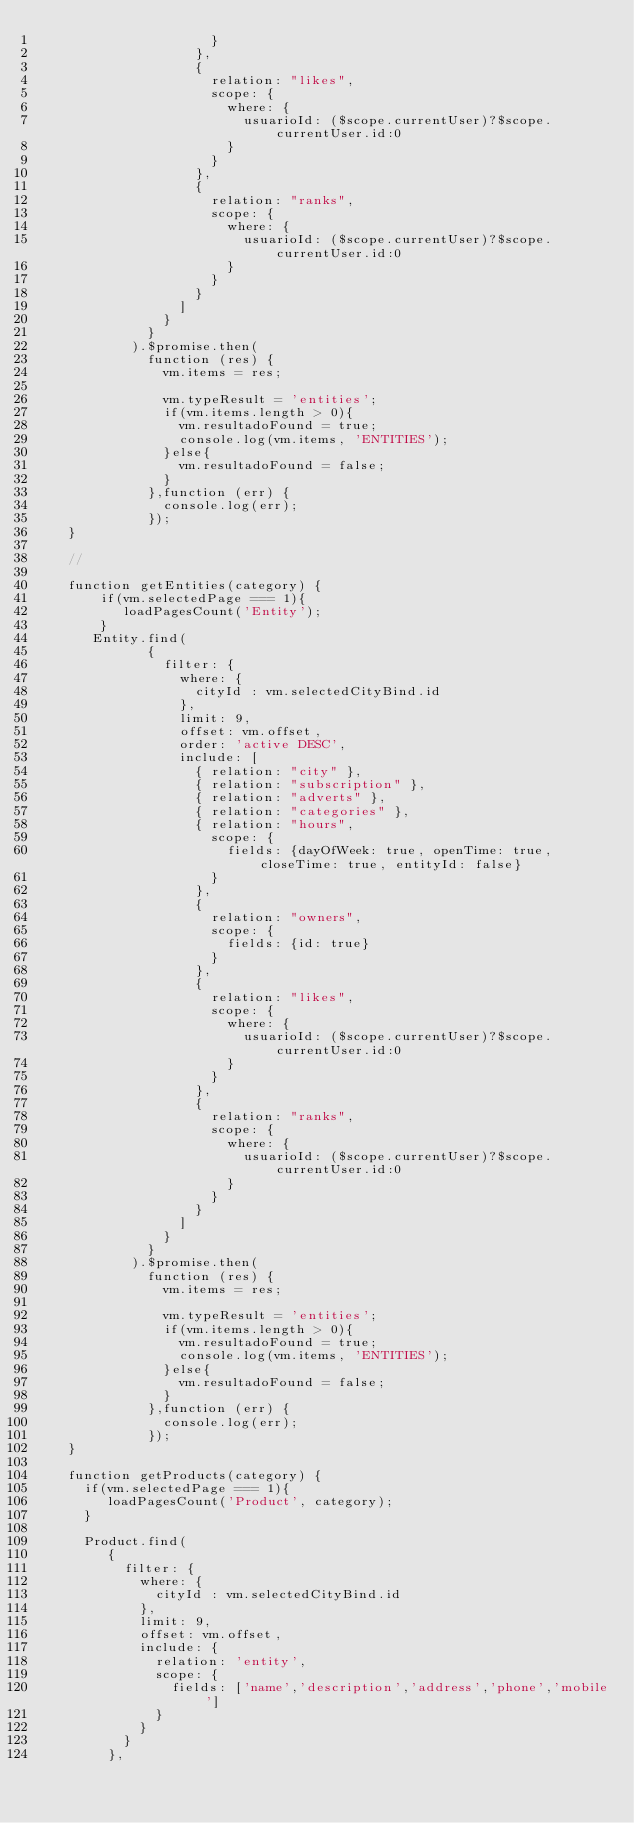Convert code to text. <code><loc_0><loc_0><loc_500><loc_500><_JavaScript_>                      }
                    },
                    {
                      relation: "likes",
                      scope: {
                        where: {
                          usuarioId: ($scope.currentUser)?$scope.currentUser.id:0
                        }
                      }
                    },
                    {
                      relation: "ranks",
                      scope: {
                        where: {
                          usuarioId: ($scope.currentUser)?$scope.currentUser.id:0
                        }
                      }
                    }
                  ]
                }
              }
            ).$promise.then(
              function (res) {
                vm.items = res;
                
                vm.typeResult = 'entities';
                if(vm.items.length > 0){
                  vm.resultadoFound = true;
                  console.log(vm.items, 'ENTITIES');
                }else{
                  vm.resultadoFound = false;
                }
              },function (err) {
                console.log(err);
              });
    }

    //

    function getEntities(category) {
        if(vm.selectedPage === 1){
           loadPagesCount('Entity');
        }
       Entity.find(
              {
                filter: {
                  where: {
                    cityId : vm.selectedCityBind.id
                  },
                  limit: 9,
                  offset: vm.offset,
                  order: 'active DESC',
                  include: [
                    { relation: "city" },
                    { relation: "subscription" },
                    { relation: "adverts" },
                    { relation: "categories" },
                    { relation: "hours",
                      scope: {
                        fields: {dayOfWeek: true, openTime: true, closeTime: true, entityId: false}
                      }
                    },
                    {
                      relation: "owners",
                      scope: {
                        fields: {id: true}
                      }
                    },
                    {
                      relation: "likes",
                      scope: {
                        where: {
                          usuarioId: ($scope.currentUser)?$scope.currentUser.id:0
                        }
                      }
                    },
                    {
                      relation: "ranks",
                      scope: {
                        where: {
                          usuarioId: ($scope.currentUser)?$scope.currentUser.id:0
                        }
                      }
                    }
                  ]
                }
              }
            ).$promise.then(
              function (res) {
                vm.items = res;
                
                vm.typeResult = 'entities';
                if(vm.items.length > 0){
                  vm.resultadoFound = true;
                  console.log(vm.items, 'ENTITIES');
                }else{
                  vm.resultadoFound = false;
                }
              },function (err) {
                console.log(err);
              });
    }

    function getProducts(category) {
      if(vm.selectedPage === 1){
         loadPagesCount('Product', category);
      }

      Product.find(
         {
           filter: {
             where: {
               cityId : vm.selectedCityBind.id
             },
             limit: 9,
             offset: vm.offset,
             include: {
               relation: 'entity',
               scope: {
                 fields: ['name','description','address','phone','mobile']
               }
             }
           }
         },</code> 